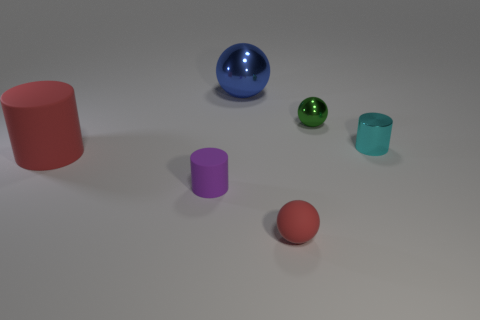There is a object that is the same color as the small matte ball; what is its material?
Your answer should be very brief. Rubber. The rubber cylinder that is right of the large cylinder is what color?
Offer a terse response. Purple. There is a metal ball that is to the left of the green metallic object; is it the same size as the small green shiny object?
Offer a very short reply. No. There is a sphere that is the same color as the large cylinder; what is its size?
Provide a short and direct response. Small. Is there a green matte cylinder of the same size as the purple cylinder?
Provide a succinct answer. No. Does the tiny cylinder that is in front of the small cyan cylinder have the same color as the cylinder that is right of the red rubber sphere?
Keep it short and to the point. No. Are there any rubber cylinders of the same color as the tiny rubber sphere?
Your response must be concise. Yes. How many other things are there of the same shape as the tiny purple matte object?
Give a very brief answer. 2. The tiny object that is on the left side of the small matte ball has what shape?
Offer a terse response. Cylinder. Do the tiny purple thing and the large object in front of the green shiny sphere have the same shape?
Provide a short and direct response. Yes. 